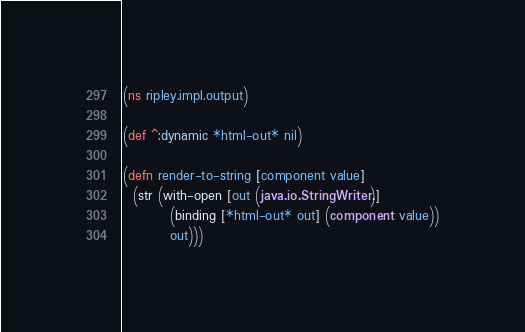Convert code to text. <code><loc_0><loc_0><loc_500><loc_500><_Clojure_>(ns ripley.impl.output)

(def ^:dynamic *html-out* nil)

(defn render-to-string [component value]
  (str (with-open [out (java.io.StringWriter.)]
         (binding [*html-out* out] (component value))
         out)))
</code> 